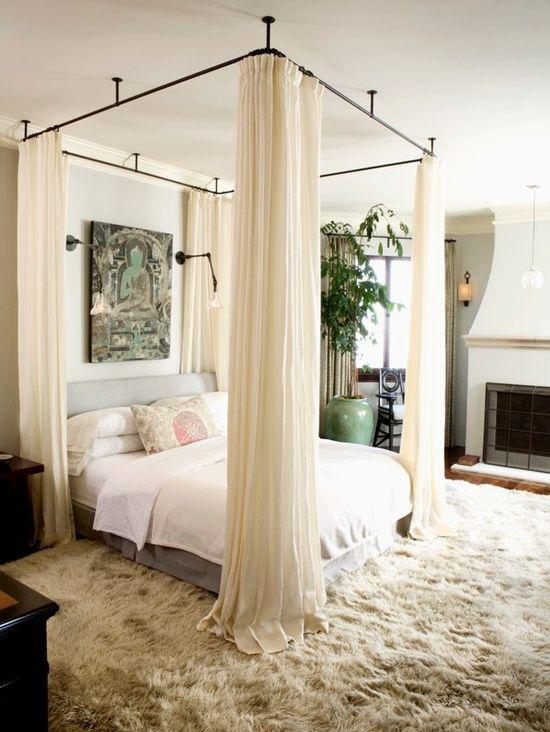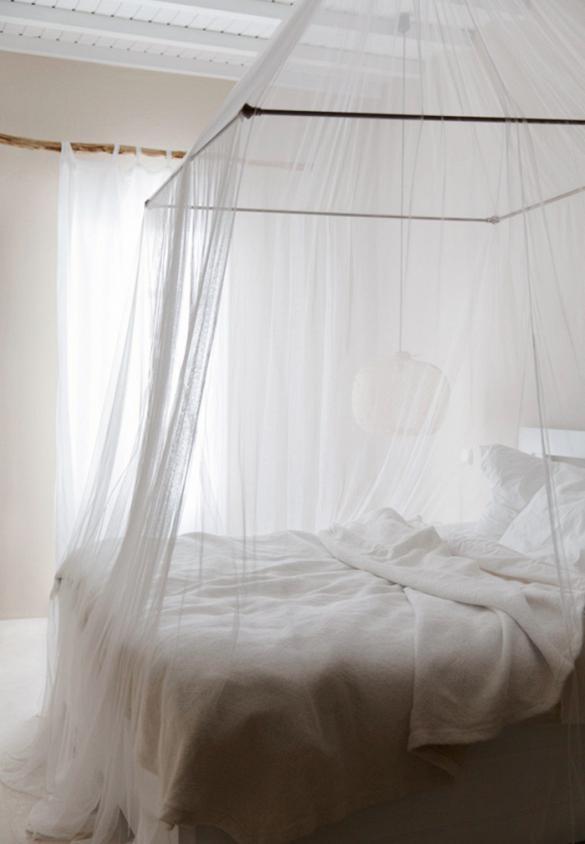The first image is the image on the left, the second image is the image on the right. Assess this claim about the two images: "The right image shows a non-white canopy.". Correct or not? Answer yes or no. No. The first image is the image on the left, the second image is the image on the right. For the images displayed, is the sentence "The netting in the right image is white." factually correct? Answer yes or no. Yes. 